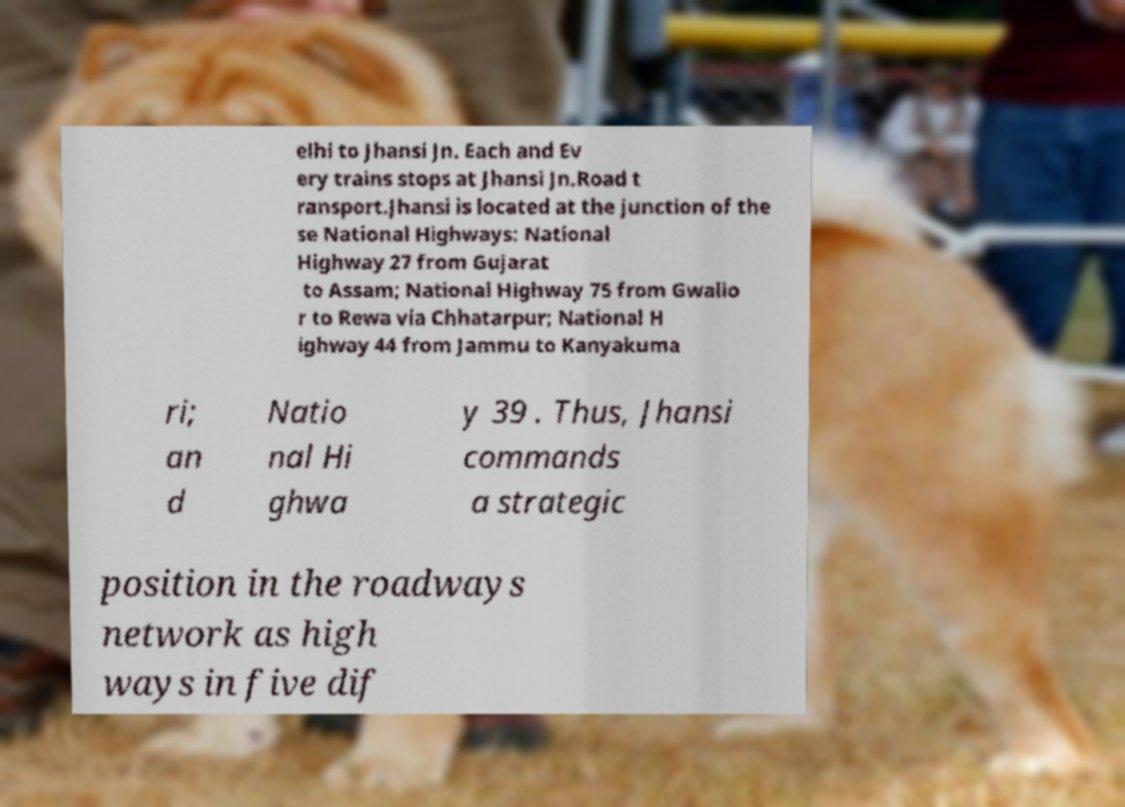Can you read and provide the text displayed in the image?This photo seems to have some interesting text. Can you extract and type it out for me? elhi to Jhansi Jn. Each and Ev ery trains stops at Jhansi Jn.Road t ransport.Jhansi is located at the junction of the se National Highways: National Highway 27 from Gujarat to Assam; National Highway 75 from Gwalio r to Rewa via Chhatarpur; National H ighway 44 from Jammu to Kanyakuma ri; an d Natio nal Hi ghwa y 39 . Thus, Jhansi commands a strategic position in the roadways network as high ways in five dif 